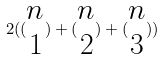<formula> <loc_0><loc_0><loc_500><loc_500>2 ( ( \begin{matrix} n \\ 1 \end{matrix} ) + ( \begin{matrix} n \\ 2 \end{matrix} ) + ( \begin{matrix} n \\ 3 \end{matrix} ) )</formula> 